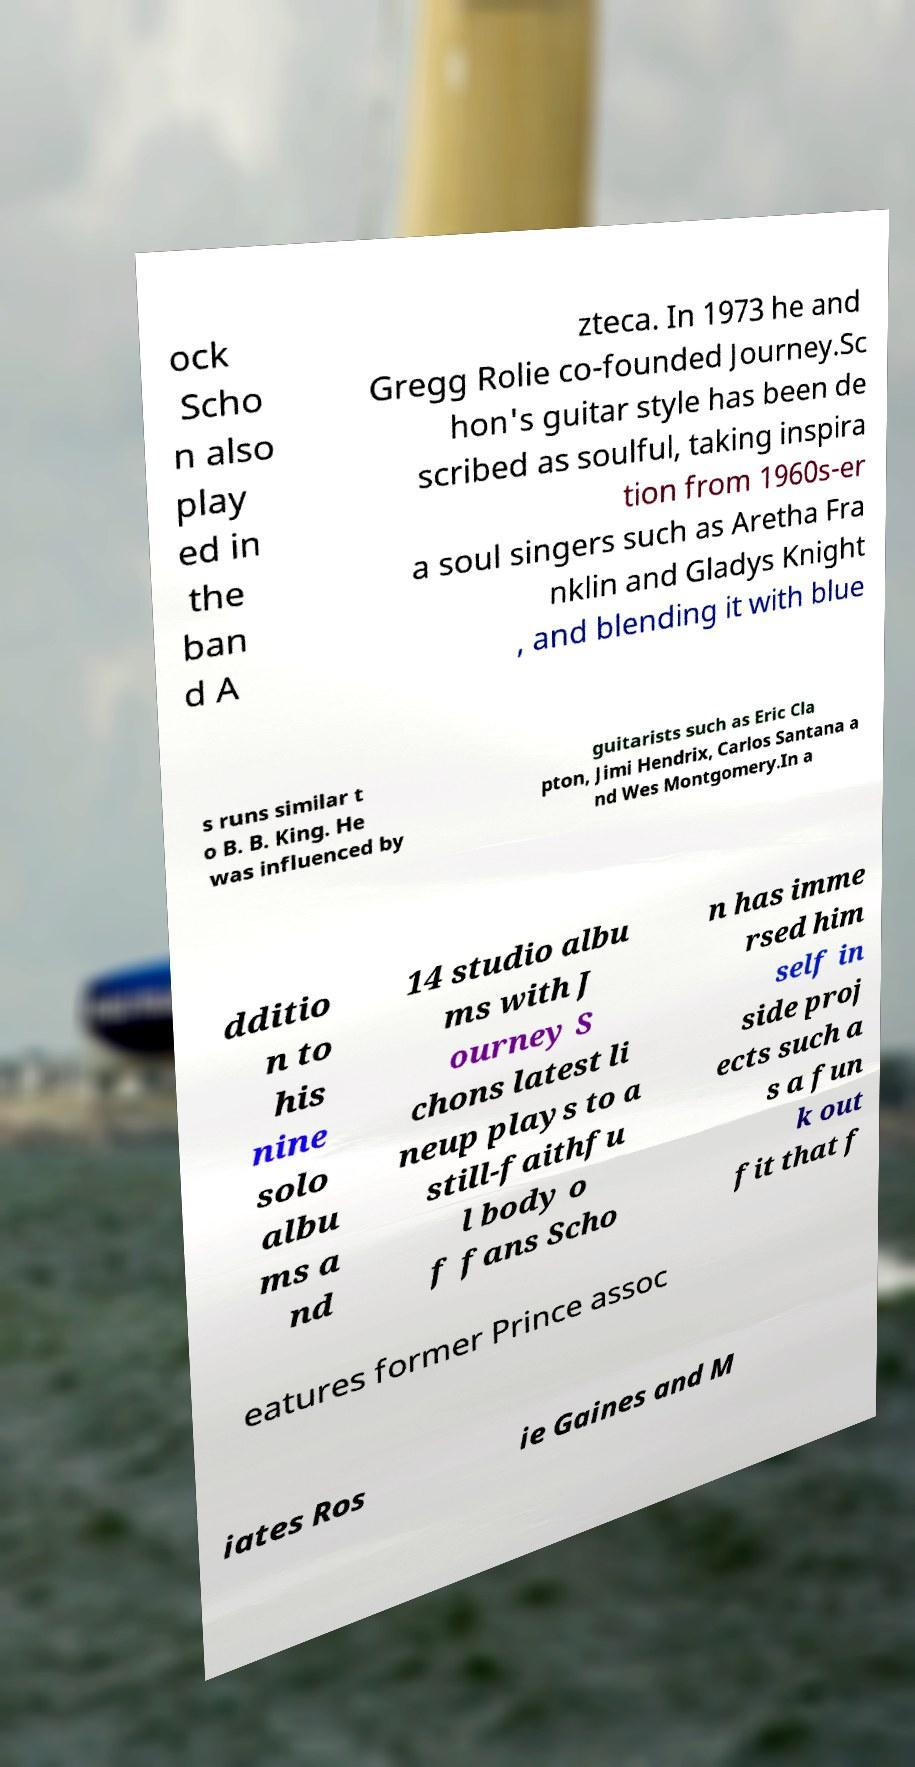Could you assist in decoding the text presented in this image and type it out clearly? ock Scho n also play ed in the ban d A zteca. In 1973 he and Gregg Rolie co-founded Journey.Sc hon's guitar style has been de scribed as soulful, taking inspira tion from 1960s-er a soul singers such as Aretha Fra nklin and Gladys Knight , and blending it with blue s runs similar t o B. B. King. He was influenced by guitarists such as Eric Cla pton, Jimi Hendrix, Carlos Santana a nd Wes Montgomery.In a dditio n to his nine solo albu ms a nd 14 studio albu ms with J ourney S chons latest li neup plays to a still-faithfu l body o f fans Scho n has imme rsed him self in side proj ects such a s a fun k out fit that f eatures former Prince assoc iates Ros ie Gaines and M 